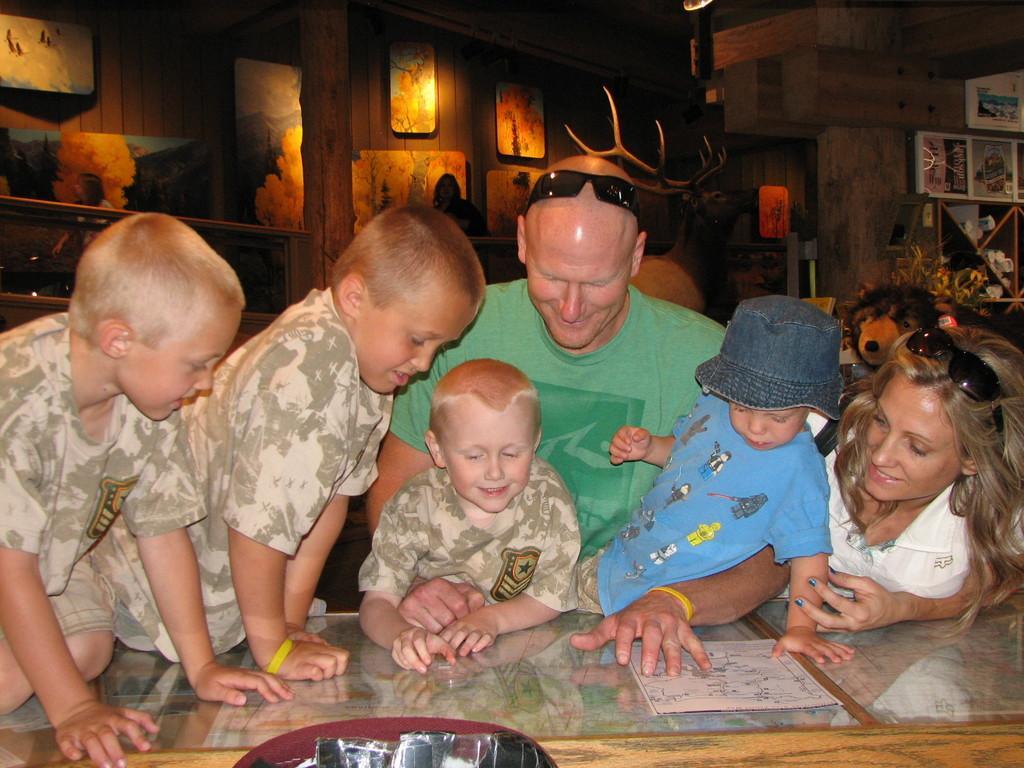In one or two sentences, can you explain what this image depicts? In this picture there are people and we can see poster on the glass table and few objects. In the background of the image animals, frames, people and few objects. 